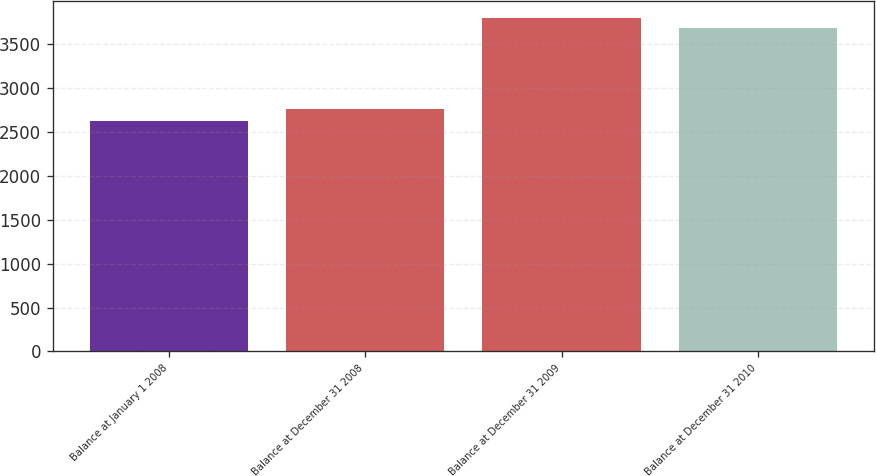<chart> <loc_0><loc_0><loc_500><loc_500><bar_chart><fcel>Balance at January 1 2008<fcel>Balance at December 31 2008<fcel>Balance at December 31 2009<fcel>Balance at December 31 2010<nl><fcel>2625<fcel>2757<fcel>3796.3<fcel>3682<nl></chart> 